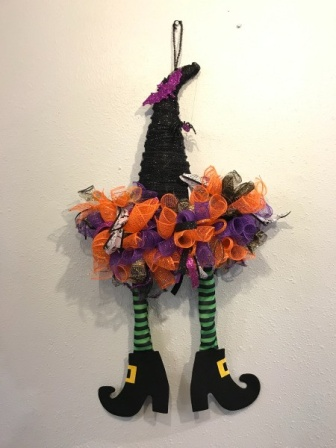Imagine an alternate universe where the witch in the decoration is the guardian of a secret realm. Describe that realm. In an alternate universe, the witch in this decoration guards the entrance to a secret, enchanted realm hidden within the walls. This realm, named 'Bewitching Hollow,' is a mysterious forest bathed in perpetual twilight, where the trees whisper ancient spells and glowing mushrooms light the paths. In the heart of the forest lies a grand castle, home to magical creatures like talking ravens, twinkling fairies, and mischievous goblins. The air is filled with the scents of exotic flowers and the sound of bubbling brooks. Every night, under the silver light of two moons, the witch hosts grand feasts and spellbinding events, where beings from across the magical spectrum gather. Potions bubble in cauldrons, and the air is alive with stories of magic and wonder. The witch, with her uncanny wisdom and playful spirit, ensures that Bewitching Hollow remains a place of harmony and enchantment. What might a visitor need to do to gain entry into this realm? To gain entry into Bewitching Hollow, a visitor must first solve a riddle presented by the witch. This riddle is no ordinary puzzle; it’s a test of wit and heart. The witch in her whimsical way will ask something profound and magical, like: 'In the shadows of the moon, what grows without roots?' The answer, known only to the kind-hearted and those who believe in magic, would be 'a dream.' Once the correct answer is given, the witch will wave her hand, and the wall will shimmer to reveal a glowing doorway. The visitor must then step through and offer a gift of pure intent, such as a feather of gratitude or a pebble of hope. This offering ensures that the visitor bears no ill will and respects the magic within. Upon entering, they are greeted with a grand welcoming by the enchanting inhabitants of Bewitching Hollow, ready to embark on an otherworldly adventure. 